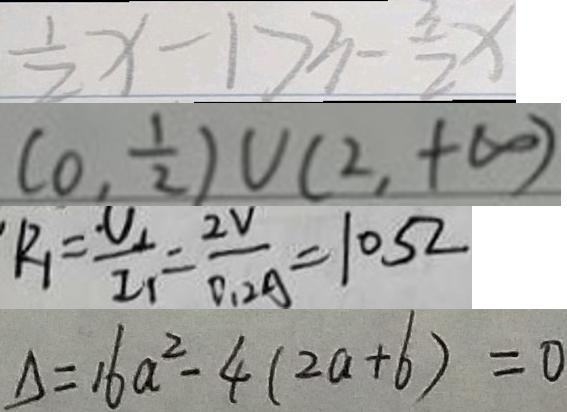Convert formula to latex. <formula><loc_0><loc_0><loc_500><loc_500>\frac { 1 } { 2 } x - 1 > 3 - \frac { 3 } { 2 } x 
 ( 0 , \frac { 1 } { 2 } ) u ( 2 , + \infty ) 
 R _ { 1 } = \frac { U _ { 1 } } { 2 _ { 1 } } = \frac { 2 V } { 0 . 2 A } = 1 0 5 2 
 \Delta = 1 6 a ^ { 2 } - 4 ( 2 a - 6 ) = 0</formula> 